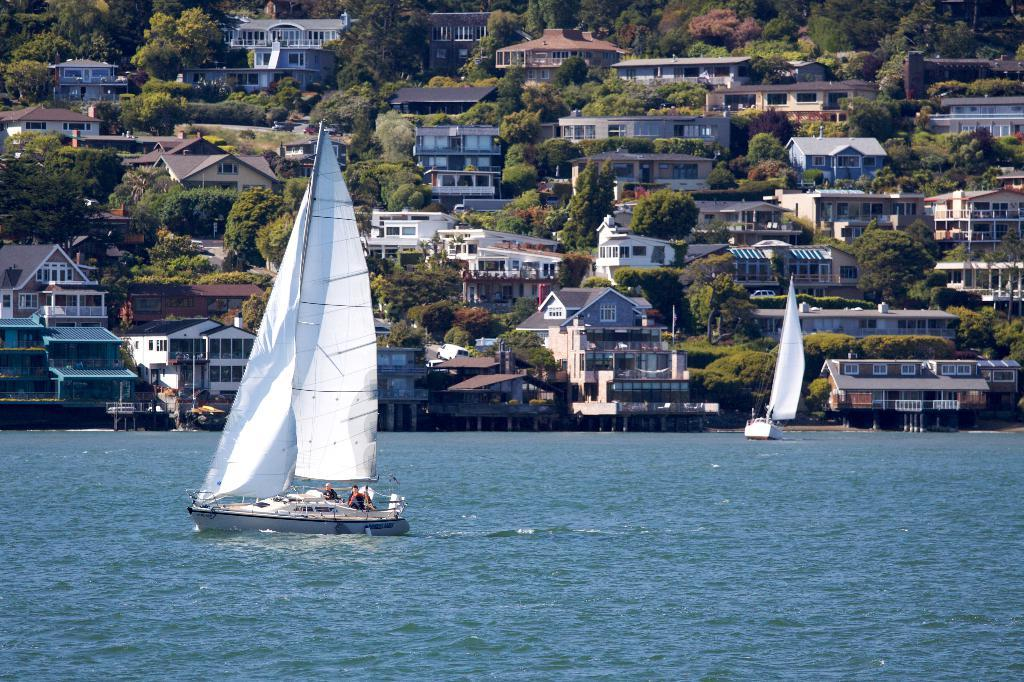What can be seen in the image related to transportation? There are two ships in the image. Where are the ships located? The ships are on a river. What can be seen in the background of the image? There are buildings and trees in the background of the image. Where can the meat be found on the shelf in the image? There is no meat or shelf present in the image. 